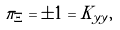<formula> <loc_0><loc_0><loc_500><loc_500>\pi _ { \Xi } = \pm 1 = K _ { y y } ,</formula> 